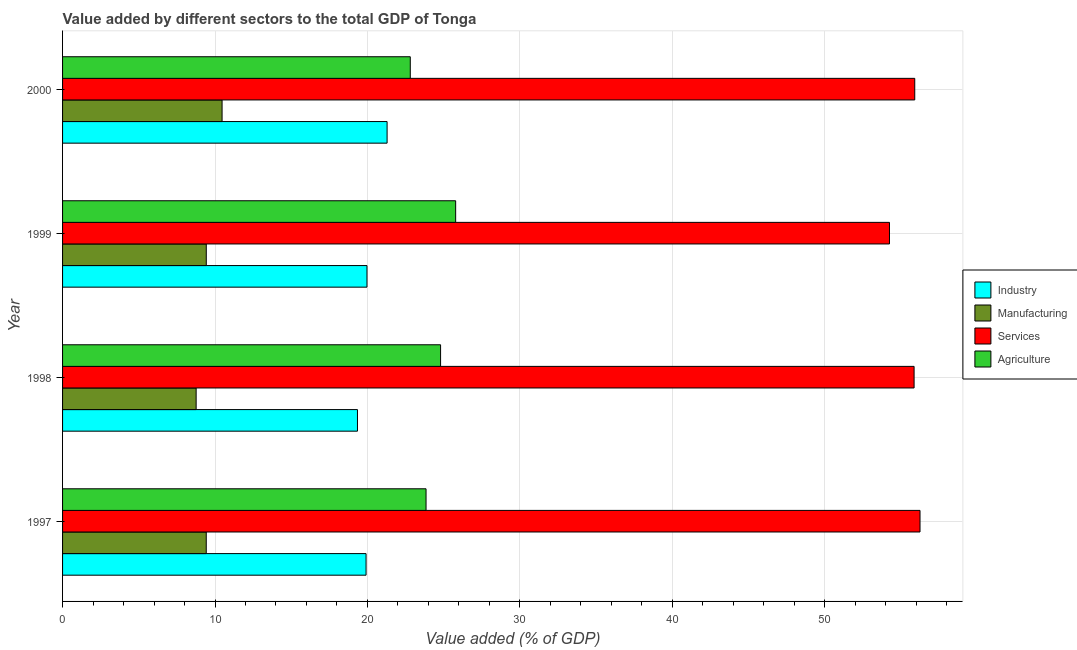How many different coloured bars are there?
Offer a very short reply. 4. How many bars are there on the 1st tick from the bottom?
Keep it short and to the point. 4. What is the value added by agricultural sector in 1999?
Make the answer very short. 25.79. Across all years, what is the maximum value added by agricultural sector?
Make the answer very short. 25.79. Across all years, what is the minimum value added by services sector?
Your answer should be compact. 54.24. What is the total value added by services sector in the graph?
Offer a terse response. 222.25. What is the difference between the value added by manufacturing sector in 1997 and that in 1998?
Provide a succinct answer. 0.66. What is the difference between the value added by agricultural sector in 1997 and the value added by manufacturing sector in 1999?
Provide a short and direct response. 14.42. What is the average value added by agricultural sector per year?
Your response must be concise. 24.31. In the year 1998, what is the difference between the value added by manufacturing sector and value added by agricultural sector?
Give a very brief answer. -16.03. What is the ratio of the value added by agricultural sector in 1997 to that in 1998?
Provide a succinct answer. 0.96. What is the difference between the highest and the second highest value added by industrial sector?
Your response must be concise. 1.32. What is the difference between the highest and the lowest value added by manufacturing sector?
Your answer should be compact. 1.7. What does the 4th bar from the top in 1998 represents?
Keep it short and to the point. Industry. What does the 4th bar from the bottom in 1998 represents?
Ensure brevity in your answer.  Agriculture. Is it the case that in every year, the sum of the value added by industrial sector and value added by manufacturing sector is greater than the value added by services sector?
Offer a terse response. No. How many bars are there?
Your answer should be compact. 16. How many years are there in the graph?
Your response must be concise. 4. What is the difference between two consecutive major ticks on the X-axis?
Your answer should be very brief. 10. Are the values on the major ticks of X-axis written in scientific E-notation?
Keep it short and to the point. No. Does the graph contain grids?
Provide a succinct answer. Yes. Where does the legend appear in the graph?
Keep it short and to the point. Center right. What is the title of the graph?
Make the answer very short. Value added by different sectors to the total GDP of Tonga. What is the label or title of the X-axis?
Provide a short and direct response. Value added (% of GDP). What is the label or title of the Y-axis?
Make the answer very short. Year. What is the Value added (% of GDP) in Industry in 1997?
Provide a short and direct response. 19.91. What is the Value added (% of GDP) in Manufacturing in 1997?
Offer a terse response. 9.43. What is the Value added (% of GDP) in Services in 1997?
Make the answer very short. 56.25. What is the Value added (% of GDP) in Agriculture in 1997?
Your answer should be very brief. 23.84. What is the Value added (% of GDP) in Industry in 1998?
Ensure brevity in your answer.  19.34. What is the Value added (% of GDP) in Manufacturing in 1998?
Provide a succinct answer. 8.76. What is the Value added (% of GDP) of Services in 1998?
Your response must be concise. 55.86. What is the Value added (% of GDP) in Agriculture in 1998?
Keep it short and to the point. 24.8. What is the Value added (% of GDP) in Industry in 1999?
Your response must be concise. 19.97. What is the Value added (% of GDP) in Manufacturing in 1999?
Your answer should be compact. 9.43. What is the Value added (% of GDP) in Services in 1999?
Keep it short and to the point. 54.24. What is the Value added (% of GDP) in Agriculture in 1999?
Provide a succinct answer. 25.79. What is the Value added (% of GDP) in Industry in 2000?
Offer a terse response. 21.29. What is the Value added (% of GDP) of Manufacturing in 2000?
Provide a succinct answer. 10.46. What is the Value added (% of GDP) in Services in 2000?
Your answer should be very brief. 55.9. What is the Value added (% of GDP) of Agriculture in 2000?
Your response must be concise. 22.81. Across all years, what is the maximum Value added (% of GDP) in Industry?
Give a very brief answer. 21.29. Across all years, what is the maximum Value added (% of GDP) of Manufacturing?
Make the answer very short. 10.46. Across all years, what is the maximum Value added (% of GDP) in Services?
Offer a very short reply. 56.25. Across all years, what is the maximum Value added (% of GDP) in Agriculture?
Provide a succinct answer. 25.79. Across all years, what is the minimum Value added (% of GDP) in Industry?
Give a very brief answer. 19.34. Across all years, what is the minimum Value added (% of GDP) in Manufacturing?
Your answer should be compact. 8.76. Across all years, what is the minimum Value added (% of GDP) of Services?
Make the answer very short. 54.24. Across all years, what is the minimum Value added (% of GDP) of Agriculture?
Your response must be concise. 22.81. What is the total Value added (% of GDP) in Industry in the graph?
Your answer should be very brief. 80.51. What is the total Value added (% of GDP) in Manufacturing in the graph?
Make the answer very short. 38.08. What is the total Value added (% of GDP) in Services in the graph?
Keep it short and to the point. 222.25. What is the total Value added (% of GDP) of Agriculture in the graph?
Provide a short and direct response. 97.24. What is the difference between the Value added (% of GDP) in Industry in 1997 and that in 1998?
Your response must be concise. 0.56. What is the difference between the Value added (% of GDP) in Manufacturing in 1997 and that in 1998?
Provide a succinct answer. 0.66. What is the difference between the Value added (% of GDP) in Services in 1997 and that in 1998?
Give a very brief answer. 0.39. What is the difference between the Value added (% of GDP) in Agriculture in 1997 and that in 1998?
Your answer should be compact. -0.95. What is the difference between the Value added (% of GDP) in Industry in 1997 and that in 1999?
Keep it short and to the point. -0.06. What is the difference between the Value added (% of GDP) in Manufacturing in 1997 and that in 1999?
Provide a succinct answer. -0. What is the difference between the Value added (% of GDP) in Services in 1997 and that in 1999?
Provide a succinct answer. 2. What is the difference between the Value added (% of GDP) of Agriculture in 1997 and that in 1999?
Make the answer very short. -1.94. What is the difference between the Value added (% of GDP) of Industry in 1997 and that in 2000?
Give a very brief answer. -1.38. What is the difference between the Value added (% of GDP) in Manufacturing in 1997 and that in 2000?
Give a very brief answer. -1.04. What is the difference between the Value added (% of GDP) in Services in 1997 and that in 2000?
Make the answer very short. 0.34. What is the difference between the Value added (% of GDP) of Agriculture in 1997 and that in 2000?
Offer a terse response. 1.03. What is the difference between the Value added (% of GDP) in Industry in 1998 and that in 1999?
Provide a short and direct response. -0.62. What is the difference between the Value added (% of GDP) of Manufacturing in 1998 and that in 1999?
Keep it short and to the point. -0.66. What is the difference between the Value added (% of GDP) in Services in 1998 and that in 1999?
Your answer should be very brief. 1.61. What is the difference between the Value added (% of GDP) of Agriculture in 1998 and that in 1999?
Ensure brevity in your answer.  -0.99. What is the difference between the Value added (% of GDP) of Industry in 1998 and that in 2000?
Give a very brief answer. -1.94. What is the difference between the Value added (% of GDP) in Manufacturing in 1998 and that in 2000?
Provide a short and direct response. -1.7. What is the difference between the Value added (% of GDP) of Services in 1998 and that in 2000?
Keep it short and to the point. -0.04. What is the difference between the Value added (% of GDP) of Agriculture in 1998 and that in 2000?
Your answer should be compact. 1.99. What is the difference between the Value added (% of GDP) in Industry in 1999 and that in 2000?
Provide a succinct answer. -1.32. What is the difference between the Value added (% of GDP) in Manufacturing in 1999 and that in 2000?
Make the answer very short. -1.04. What is the difference between the Value added (% of GDP) in Services in 1999 and that in 2000?
Ensure brevity in your answer.  -1.66. What is the difference between the Value added (% of GDP) of Agriculture in 1999 and that in 2000?
Offer a terse response. 2.98. What is the difference between the Value added (% of GDP) of Industry in 1997 and the Value added (% of GDP) of Manufacturing in 1998?
Your answer should be compact. 11.15. What is the difference between the Value added (% of GDP) of Industry in 1997 and the Value added (% of GDP) of Services in 1998?
Make the answer very short. -35.95. What is the difference between the Value added (% of GDP) in Industry in 1997 and the Value added (% of GDP) in Agriculture in 1998?
Make the answer very short. -4.89. What is the difference between the Value added (% of GDP) of Manufacturing in 1997 and the Value added (% of GDP) of Services in 1998?
Your answer should be very brief. -46.43. What is the difference between the Value added (% of GDP) in Manufacturing in 1997 and the Value added (% of GDP) in Agriculture in 1998?
Provide a succinct answer. -15.37. What is the difference between the Value added (% of GDP) of Services in 1997 and the Value added (% of GDP) of Agriculture in 1998?
Offer a terse response. 31.45. What is the difference between the Value added (% of GDP) in Industry in 1997 and the Value added (% of GDP) in Manufacturing in 1999?
Keep it short and to the point. 10.48. What is the difference between the Value added (% of GDP) in Industry in 1997 and the Value added (% of GDP) in Services in 1999?
Provide a succinct answer. -34.34. What is the difference between the Value added (% of GDP) in Industry in 1997 and the Value added (% of GDP) in Agriculture in 1999?
Your answer should be compact. -5.88. What is the difference between the Value added (% of GDP) in Manufacturing in 1997 and the Value added (% of GDP) in Services in 1999?
Ensure brevity in your answer.  -44.82. What is the difference between the Value added (% of GDP) in Manufacturing in 1997 and the Value added (% of GDP) in Agriculture in 1999?
Provide a succinct answer. -16.36. What is the difference between the Value added (% of GDP) of Services in 1997 and the Value added (% of GDP) of Agriculture in 1999?
Offer a very short reply. 30.46. What is the difference between the Value added (% of GDP) of Industry in 1997 and the Value added (% of GDP) of Manufacturing in 2000?
Ensure brevity in your answer.  9.44. What is the difference between the Value added (% of GDP) in Industry in 1997 and the Value added (% of GDP) in Services in 2000?
Give a very brief answer. -35.99. What is the difference between the Value added (% of GDP) in Industry in 1997 and the Value added (% of GDP) in Agriculture in 2000?
Your answer should be very brief. -2.9. What is the difference between the Value added (% of GDP) in Manufacturing in 1997 and the Value added (% of GDP) in Services in 2000?
Offer a very short reply. -46.48. What is the difference between the Value added (% of GDP) of Manufacturing in 1997 and the Value added (% of GDP) of Agriculture in 2000?
Make the answer very short. -13.38. What is the difference between the Value added (% of GDP) of Services in 1997 and the Value added (% of GDP) of Agriculture in 2000?
Your answer should be compact. 33.44. What is the difference between the Value added (% of GDP) of Industry in 1998 and the Value added (% of GDP) of Manufacturing in 1999?
Your answer should be compact. 9.92. What is the difference between the Value added (% of GDP) in Industry in 1998 and the Value added (% of GDP) in Services in 1999?
Provide a short and direct response. -34.9. What is the difference between the Value added (% of GDP) in Industry in 1998 and the Value added (% of GDP) in Agriculture in 1999?
Provide a succinct answer. -6.44. What is the difference between the Value added (% of GDP) in Manufacturing in 1998 and the Value added (% of GDP) in Services in 1999?
Provide a short and direct response. -45.48. What is the difference between the Value added (% of GDP) in Manufacturing in 1998 and the Value added (% of GDP) in Agriculture in 1999?
Offer a very short reply. -17.02. What is the difference between the Value added (% of GDP) in Services in 1998 and the Value added (% of GDP) in Agriculture in 1999?
Ensure brevity in your answer.  30.07. What is the difference between the Value added (% of GDP) in Industry in 1998 and the Value added (% of GDP) in Manufacturing in 2000?
Offer a terse response. 8.88. What is the difference between the Value added (% of GDP) in Industry in 1998 and the Value added (% of GDP) in Services in 2000?
Offer a terse response. -36.56. What is the difference between the Value added (% of GDP) of Industry in 1998 and the Value added (% of GDP) of Agriculture in 2000?
Provide a succinct answer. -3.46. What is the difference between the Value added (% of GDP) of Manufacturing in 1998 and the Value added (% of GDP) of Services in 2000?
Provide a short and direct response. -47.14. What is the difference between the Value added (% of GDP) of Manufacturing in 1998 and the Value added (% of GDP) of Agriculture in 2000?
Your answer should be compact. -14.05. What is the difference between the Value added (% of GDP) of Services in 1998 and the Value added (% of GDP) of Agriculture in 2000?
Keep it short and to the point. 33.05. What is the difference between the Value added (% of GDP) in Industry in 1999 and the Value added (% of GDP) in Manufacturing in 2000?
Provide a succinct answer. 9.51. What is the difference between the Value added (% of GDP) of Industry in 1999 and the Value added (% of GDP) of Services in 2000?
Offer a very short reply. -35.93. What is the difference between the Value added (% of GDP) of Industry in 1999 and the Value added (% of GDP) of Agriculture in 2000?
Your answer should be compact. -2.84. What is the difference between the Value added (% of GDP) in Manufacturing in 1999 and the Value added (% of GDP) in Services in 2000?
Keep it short and to the point. -46.48. What is the difference between the Value added (% of GDP) in Manufacturing in 1999 and the Value added (% of GDP) in Agriculture in 2000?
Give a very brief answer. -13.38. What is the difference between the Value added (% of GDP) of Services in 1999 and the Value added (% of GDP) of Agriculture in 2000?
Your response must be concise. 31.44. What is the average Value added (% of GDP) in Industry per year?
Keep it short and to the point. 20.13. What is the average Value added (% of GDP) of Manufacturing per year?
Ensure brevity in your answer.  9.52. What is the average Value added (% of GDP) in Services per year?
Your answer should be compact. 55.56. What is the average Value added (% of GDP) of Agriculture per year?
Your answer should be compact. 24.31. In the year 1997, what is the difference between the Value added (% of GDP) in Industry and Value added (% of GDP) in Manufacturing?
Ensure brevity in your answer.  10.48. In the year 1997, what is the difference between the Value added (% of GDP) in Industry and Value added (% of GDP) in Services?
Your answer should be very brief. -36.34. In the year 1997, what is the difference between the Value added (% of GDP) of Industry and Value added (% of GDP) of Agriculture?
Make the answer very short. -3.94. In the year 1997, what is the difference between the Value added (% of GDP) of Manufacturing and Value added (% of GDP) of Services?
Your answer should be compact. -46.82. In the year 1997, what is the difference between the Value added (% of GDP) of Manufacturing and Value added (% of GDP) of Agriculture?
Make the answer very short. -14.42. In the year 1997, what is the difference between the Value added (% of GDP) in Services and Value added (% of GDP) in Agriculture?
Ensure brevity in your answer.  32.4. In the year 1998, what is the difference between the Value added (% of GDP) in Industry and Value added (% of GDP) in Manufacturing?
Give a very brief answer. 10.58. In the year 1998, what is the difference between the Value added (% of GDP) in Industry and Value added (% of GDP) in Services?
Keep it short and to the point. -36.51. In the year 1998, what is the difference between the Value added (% of GDP) of Industry and Value added (% of GDP) of Agriculture?
Your answer should be compact. -5.45. In the year 1998, what is the difference between the Value added (% of GDP) of Manufacturing and Value added (% of GDP) of Services?
Your response must be concise. -47.1. In the year 1998, what is the difference between the Value added (% of GDP) in Manufacturing and Value added (% of GDP) in Agriculture?
Ensure brevity in your answer.  -16.03. In the year 1998, what is the difference between the Value added (% of GDP) of Services and Value added (% of GDP) of Agriculture?
Keep it short and to the point. 31.06. In the year 1999, what is the difference between the Value added (% of GDP) of Industry and Value added (% of GDP) of Manufacturing?
Your answer should be very brief. 10.54. In the year 1999, what is the difference between the Value added (% of GDP) in Industry and Value added (% of GDP) in Services?
Keep it short and to the point. -34.28. In the year 1999, what is the difference between the Value added (% of GDP) of Industry and Value added (% of GDP) of Agriculture?
Keep it short and to the point. -5.82. In the year 1999, what is the difference between the Value added (% of GDP) of Manufacturing and Value added (% of GDP) of Services?
Provide a succinct answer. -44.82. In the year 1999, what is the difference between the Value added (% of GDP) of Manufacturing and Value added (% of GDP) of Agriculture?
Ensure brevity in your answer.  -16.36. In the year 1999, what is the difference between the Value added (% of GDP) of Services and Value added (% of GDP) of Agriculture?
Give a very brief answer. 28.46. In the year 2000, what is the difference between the Value added (% of GDP) in Industry and Value added (% of GDP) in Manufacturing?
Ensure brevity in your answer.  10.82. In the year 2000, what is the difference between the Value added (% of GDP) in Industry and Value added (% of GDP) in Services?
Offer a very short reply. -34.61. In the year 2000, what is the difference between the Value added (% of GDP) in Industry and Value added (% of GDP) in Agriculture?
Offer a terse response. -1.52. In the year 2000, what is the difference between the Value added (% of GDP) of Manufacturing and Value added (% of GDP) of Services?
Ensure brevity in your answer.  -45.44. In the year 2000, what is the difference between the Value added (% of GDP) in Manufacturing and Value added (% of GDP) in Agriculture?
Ensure brevity in your answer.  -12.35. In the year 2000, what is the difference between the Value added (% of GDP) in Services and Value added (% of GDP) in Agriculture?
Your response must be concise. 33.09. What is the ratio of the Value added (% of GDP) in Industry in 1997 to that in 1998?
Your answer should be very brief. 1.03. What is the ratio of the Value added (% of GDP) of Manufacturing in 1997 to that in 1998?
Offer a terse response. 1.08. What is the ratio of the Value added (% of GDP) in Agriculture in 1997 to that in 1998?
Make the answer very short. 0.96. What is the ratio of the Value added (% of GDP) in Industry in 1997 to that in 1999?
Your answer should be compact. 1. What is the ratio of the Value added (% of GDP) in Manufacturing in 1997 to that in 1999?
Keep it short and to the point. 1. What is the ratio of the Value added (% of GDP) of Services in 1997 to that in 1999?
Your response must be concise. 1.04. What is the ratio of the Value added (% of GDP) in Agriculture in 1997 to that in 1999?
Ensure brevity in your answer.  0.92. What is the ratio of the Value added (% of GDP) in Industry in 1997 to that in 2000?
Provide a succinct answer. 0.94. What is the ratio of the Value added (% of GDP) in Manufacturing in 1997 to that in 2000?
Your answer should be very brief. 0.9. What is the ratio of the Value added (% of GDP) in Agriculture in 1997 to that in 2000?
Make the answer very short. 1.05. What is the ratio of the Value added (% of GDP) in Industry in 1998 to that in 1999?
Keep it short and to the point. 0.97. What is the ratio of the Value added (% of GDP) in Manufacturing in 1998 to that in 1999?
Your response must be concise. 0.93. What is the ratio of the Value added (% of GDP) in Services in 1998 to that in 1999?
Offer a very short reply. 1.03. What is the ratio of the Value added (% of GDP) in Agriculture in 1998 to that in 1999?
Offer a terse response. 0.96. What is the ratio of the Value added (% of GDP) in Industry in 1998 to that in 2000?
Offer a terse response. 0.91. What is the ratio of the Value added (% of GDP) of Manufacturing in 1998 to that in 2000?
Make the answer very short. 0.84. What is the ratio of the Value added (% of GDP) of Agriculture in 1998 to that in 2000?
Ensure brevity in your answer.  1.09. What is the ratio of the Value added (% of GDP) of Industry in 1999 to that in 2000?
Provide a short and direct response. 0.94. What is the ratio of the Value added (% of GDP) in Manufacturing in 1999 to that in 2000?
Offer a terse response. 0.9. What is the ratio of the Value added (% of GDP) in Services in 1999 to that in 2000?
Your answer should be compact. 0.97. What is the ratio of the Value added (% of GDP) of Agriculture in 1999 to that in 2000?
Your response must be concise. 1.13. What is the difference between the highest and the second highest Value added (% of GDP) in Industry?
Provide a succinct answer. 1.32. What is the difference between the highest and the second highest Value added (% of GDP) of Manufacturing?
Keep it short and to the point. 1.04. What is the difference between the highest and the second highest Value added (% of GDP) of Services?
Your response must be concise. 0.34. What is the difference between the highest and the second highest Value added (% of GDP) of Agriculture?
Give a very brief answer. 0.99. What is the difference between the highest and the lowest Value added (% of GDP) of Industry?
Your response must be concise. 1.94. What is the difference between the highest and the lowest Value added (% of GDP) in Manufacturing?
Keep it short and to the point. 1.7. What is the difference between the highest and the lowest Value added (% of GDP) of Services?
Your answer should be very brief. 2. What is the difference between the highest and the lowest Value added (% of GDP) of Agriculture?
Offer a very short reply. 2.98. 